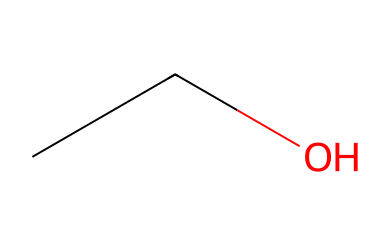What is the molecular formula of this chemical? The SMILES representation "CCO" translates to C2H6O, indicating the presence of 2 carbon atoms, 6 hydrogen atoms, and 1 oxygen atom.
Answer: C2H6O How many carbon atoms are in this molecule? By analyzing the SMILES notation "CCO", we can see that there are two 'C' characters, representing two carbon atoms in the structure.
Answer: 2 What is the functional group present in this molecule? The presence of the -OH group in the structure of ethanol indicates that it is an alcohol, which is defined by this hydroxyl functional group.
Answer: hydroxyl What type of compound is ethanol classified as? Ethanol, represented by the SMILES "CCO", is classified as an alcohol, a type of organic compound characterized by having a hydroxyl group attached to a carbon chain.
Answer: alcohol Does this molecule contain any double bonds? The SMILES notation “CCO” has only single bonds between the carbon and oxygen atoms, indicating that there are no double bonds present in this molecule.
Answer: no How many hydrogen atoms are bonded to the first carbon? Noting the structure from the SMILES, the first carbon (attached to two hydrogen atoms) is bonded to only one other carbon, implying there are three hydrogens in total for this carbon: two from the carbon and one that links to the next.
Answer: 3 